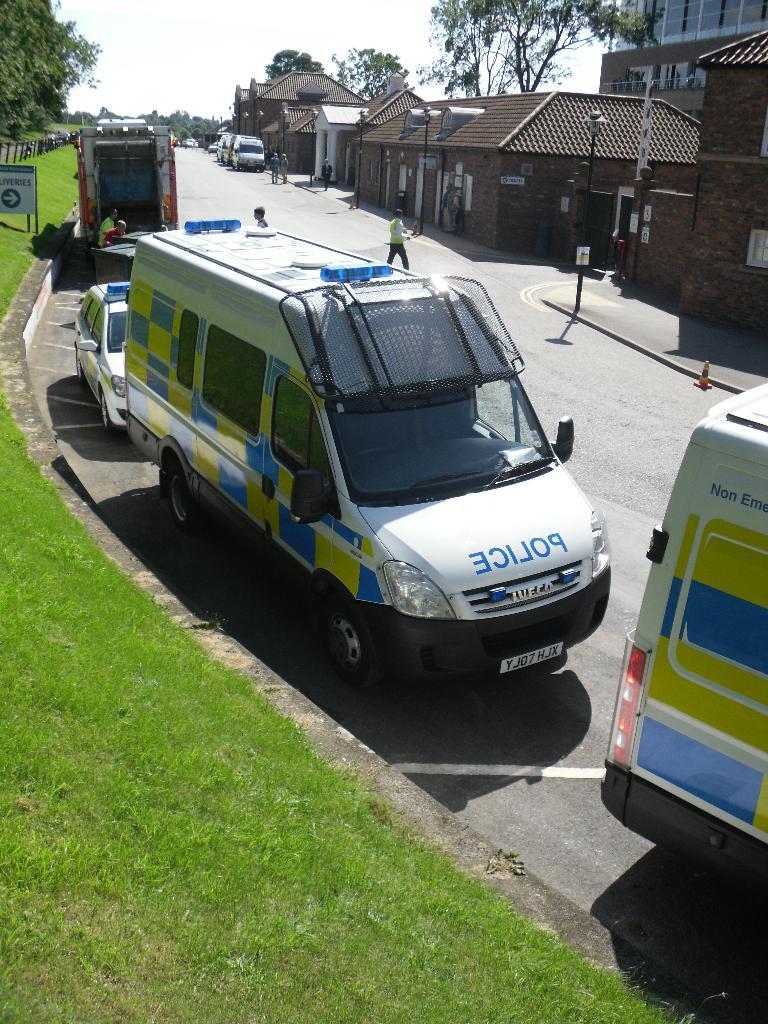Could you give a brief overview of what you see in this image? In this i made in the middle on the road there are few vehicles. People are walking on the road. On the top there are many buildings, trees. Beside the road there are street lights. In the left there are trees, sign board. The sky is clear. 